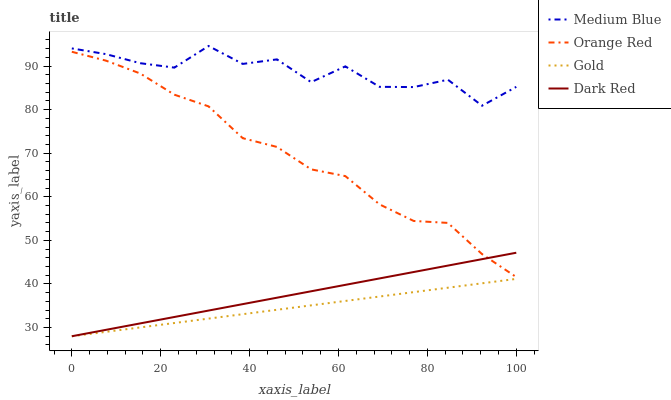Does Gold have the minimum area under the curve?
Answer yes or no. Yes. Does Medium Blue have the maximum area under the curve?
Answer yes or no. Yes. Does Orange Red have the minimum area under the curve?
Answer yes or no. No. Does Orange Red have the maximum area under the curve?
Answer yes or no. No. Is Dark Red the smoothest?
Answer yes or no. Yes. Is Medium Blue the roughest?
Answer yes or no. Yes. Is Orange Red the smoothest?
Answer yes or no. No. Is Orange Red the roughest?
Answer yes or no. No. Does Dark Red have the lowest value?
Answer yes or no. Yes. Does Orange Red have the lowest value?
Answer yes or no. No. Does Medium Blue have the highest value?
Answer yes or no. Yes. Does Orange Red have the highest value?
Answer yes or no. No. Is Orange Red less than Medium Blue?
Answer yes or no. Yes. Is Medium Blue greater than Orange Red?
Answer yes or no. Yes. Does Dark Red intersect Orange Red?
Answer yes or no. Yes. Is Dark Red less than Orange Red?
Answer yes or no. No. Is Dark Red greater than Orange Red?
Answer yes or no. No. Does Orange Red intersect Medium Blue?
Answer yes or no. No. 